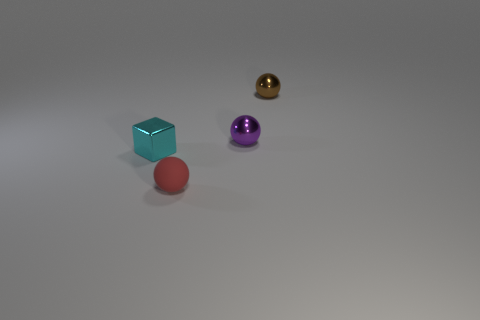Is there anything else that has the same material as the small red sphere?
Keep it short and to the point. No. Is there anything else that is the same shape as the cyan metal thing?
Your response must be concise. No. The small shiny object that is to the left of the small red matte ball in front of the small purple ball is what shape?
Offer a terse response. Cube. The tiny cyan thing that is made of the same material as the tiny brown sphere is what shape?
Provide a succinct answer. Cube. How big is the shiny sphere that is on the left side of the tiny sphere that is right of the purple metallic sphere?
Offer a terse response. Small. What is the shape of the small cyan metal object?
Give a very brief answer. Cube. What number of big things are either purple things or metal cylinders?
Make the answer very short. 0. There is a purple thing that is the same shape as the brown metallic thing; what is its size?
Make the answer very short. Small. What number of balls are to the left of the small purple sphere and to the right of the small red ball?
Make the answer very short. 0. There is a rubber object; does it have the same shape as the thing left of the rubber ball?
Your response must be concise. No. 